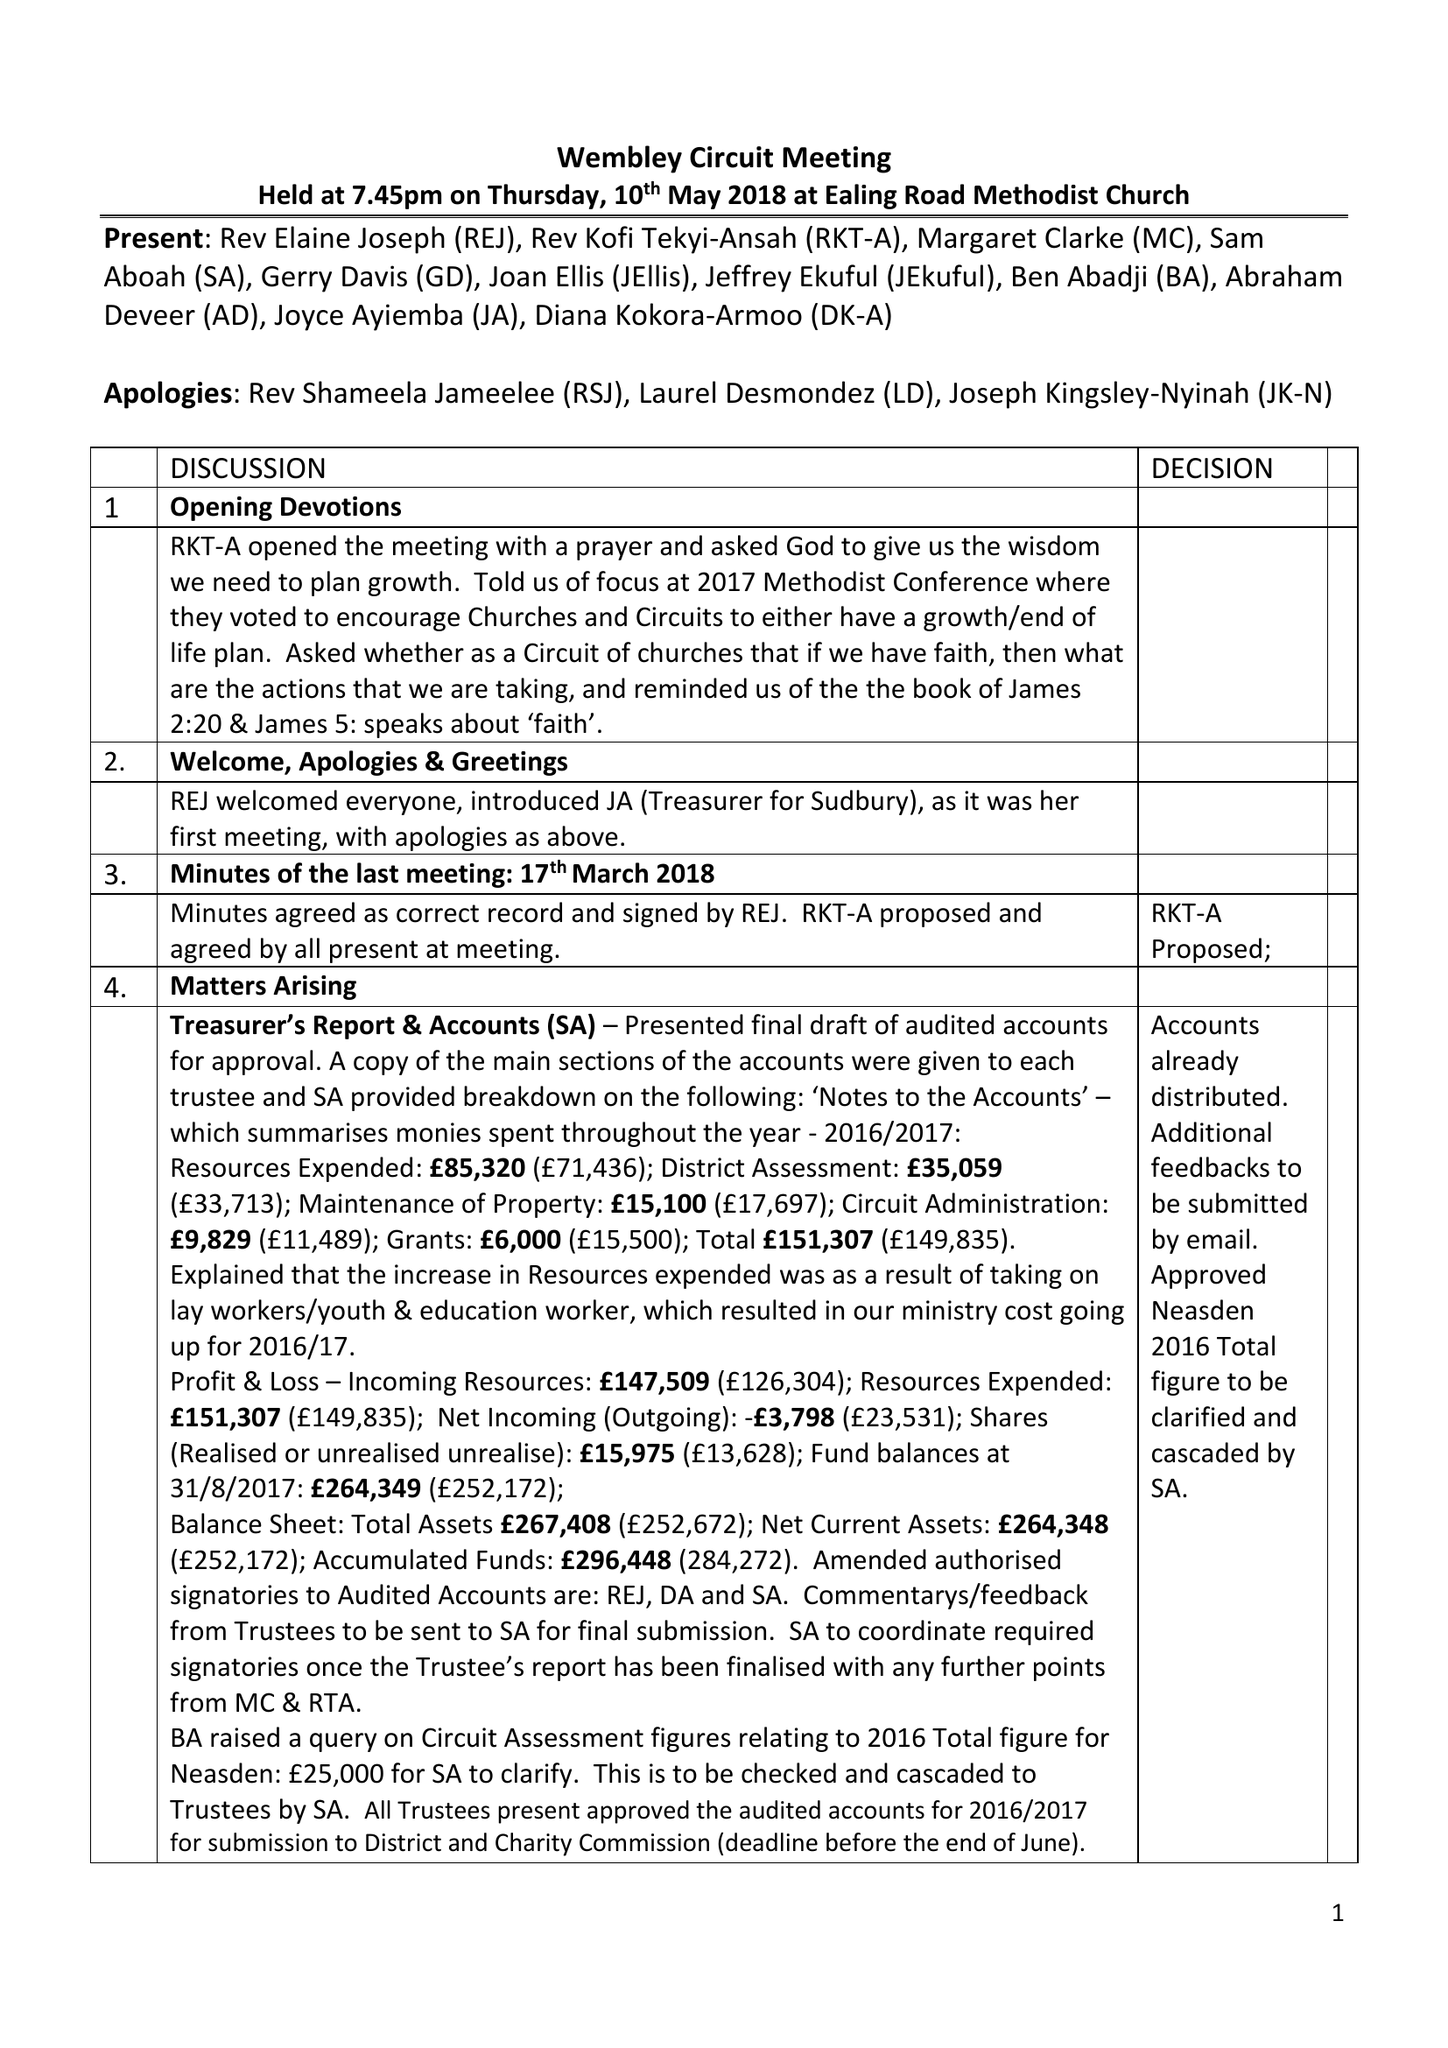What is the value for the address__postcode?
Answer the question using a single word or phrase. HA9 7QR 